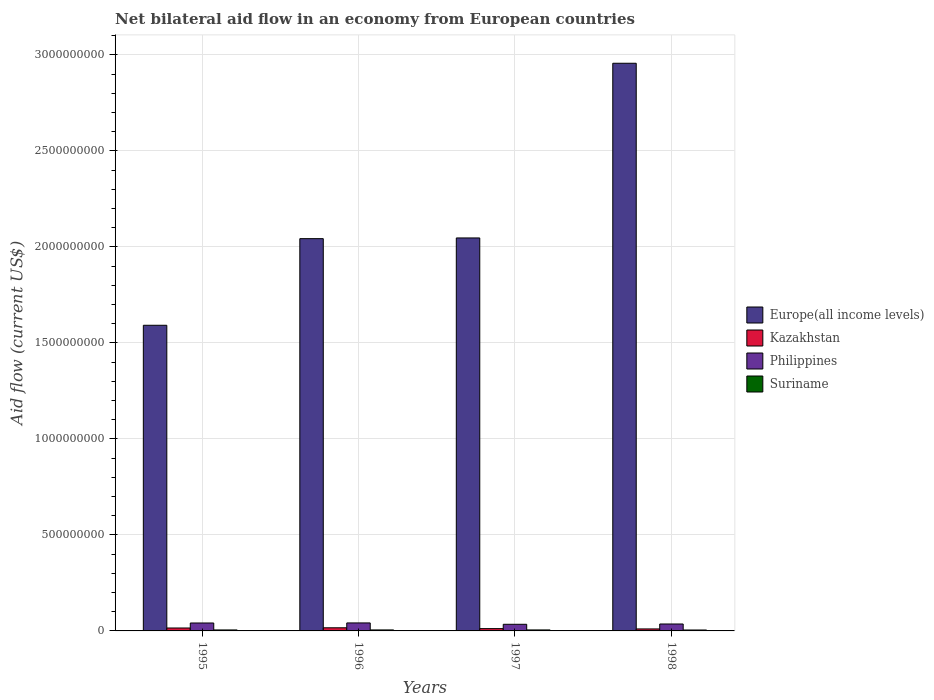How many different coloured bars are there?
Make the answer very short. 4. How many groups of bars are there?
Make the answer very short. 4. Are the number of bars on each tick of the X-axis equal?
Offer a very short reply. Yes. How many bars are there on the 2nd tick from the left?
Your answer should be compact. 4. How many bars are there on the 4th tick from the right?
Give a very brief answer. 4. In how many cases, is the number of bars for a given year not equal to the number of legend labels?
Make the answer very short. 0. What is the net bilateral aid flow in Kazakhstan in 1996?
Your answer should be very brief. 1.63e+07. Across all years, what is the maximum net bilateral aid flow in Philippines?
Give a very brief answer. 4.17e+07. Across all years, what is the minimum net bilateral aid flow in Europe(all income levels)?
Offer a very short reply. 1.59e+09. In which year was the net bilateral aid flow in Kazakhstan minimum?
Ensure brevity in your answer.  1998. What is the total net bilateral aid flow in Suriname in the graph?
Offer a very short reply. 2.02e+07. What is the difference between the net bilateral aid flow in Kazakhstan in 1996 and that in 1998?
Provide a short and direct response. 5.98e+06. What is the difference between the net bilateral aid flow in Europe(all income levels) in 1998 and the net bilateral aid flow in Kazakhstan in 1995?
Give a very brief answer. 2.94e+09. What is the average net bilateral aid flow in Suriname per year?
Make the answer very short. 5.06e+06. In the year 1996, what is the difference between the net bilateral aid flow in Philippines and net bilateral aid flow in Europe(all income levels)?
Offer a very short reply. -2.00e+09. What is the ratio of the net bilateral aid flow in Europe(all income levels) in 1995 to that in 1996?
Offer a very short reply. 0.78. Is the net bilateral aid flow in Suriname in 1995 less than that in 1997?
Offer a very short reply. Yes. What is the difference between the highest and the second highest net bilateral aid flow in Kazakhstan?
Keep it short and to the point. 1.10e+06. What is the difference between the highest and the lowest net bilateral aid flow in Europe(all income levels)?
Offer a very short reply. 1.36e+09. Is it the case that in every year, the sum of the net bilateral aid flow in Kazakhstan and net bilateral aid flow in Suriname is greater than the sum of net bilateral aid flow in Philippines and net bilateral aid flow in Europe(all income levels)?
Give a very brief answer. No. What does the 2nd bar from the left in 1996 represents?
Your answer should be very brief. Kazakhstan. What does the 4th bar from the right in 1996 represents?
Give a very brief answer. Europe(all income levels). Is it the case that in every year, the sum of the net bilateral aid flow in Kazakhstan and net bilateral aid flow in Europe(all income levels) is greater than the net bilateral aid flow in Suriname?
Give a very brief answer. Yes. How many bars are there?
Give a very brief answer. 16. Are all the bars in the graph horizontal?
Ensure brevity in your answer.  No. How many years are there in the graph?
Offer a terse response. 4. Does the graph contain grids?
Keep it short and to the point. Yes. How many legend labels are there?
Provide a short and direct response. 4. How are the legend labels stacked?
Offer a terse response. Vertical. What is the title of the graph?
Give a very brief answer. Net bilateral aid flow in an economy from European countries. Does "Oman" appear as one of the legend labels in the graph?
Keep it short and to the point. No. What is the label or title of the Y-axis?
Offer a terse response. Aid flow (current US$). What is the Aid flow (current US$) of Europe(all income levels) in 1995?
Keep it short and to the point. 1.59e+09. What is the Aid flow (current US$) of Kazakhstan in 1995?
Keep it short and to the point. 1.52e+07. What is the Aid flow (current US$) in Philippines in 1995?
Give a very brief answer. 4.13e+07. What is the Aid flow (current US$) of Suriname in 1995?
Provide a succinct answer. 5.12e+06. What is the Aid flow (current US$) in Europe(all income levels) in 1996?
Your answer should be very brief. 2.04e+09. What is the Aid flow (current US$) of Kazakhstan in 1996?
Your response must be concise. 1.63e+07. What is the Aid flow (current US$) in Philippines in 1996?
Provide a short and direct response. 4.17e+07. What is the Aid flow (current US$) of Suriname in 1996?
Offer a terse response. 5.17e+06. What is the Aid flow (current US$) in Europe(all income levels) in 1997?
Offer a very short reply. 2.05e+09. What is the Aid flow (current US$) of Kazakhstan in 1997?
Give a very brief answer. 1.20e+07. What is the Aid flow (current US$) of Philippines in 1997?
Offer a very short reply. 3.45e+07. What is the Aid flow (current US$) in Suriname in 1997?
Offer a terse response. 5.15e+06. What is the Aid flow (current US$) in Europe(all income levels) in 1998?
Make the answer very short. 2.96e+09. What is the Aid flow (current US$) in Kazakhstan in 1998?
Provide a succinct answer. 1.04e+07. What is the Aid flow (current US$) in Philippines in 1998?
Give a very brief answer. 3.61e+07. What is the Aid flow (current US$) of Suriname in 1998?
Provide a succinct answer. 4.81e+06. Across all years, what is the maximum Aid flow (current US$) of Europe(all income levels)?
Make the answer very short. 2.96e+09. Across all years, what is the maximum Aid flow (current US$) in Kazakhstan?
Offer a terse response. 1.63e+07. Across all years, what is the maximum Aid flow (current US$) in Philippines?
Offer a very short reply. 4.17e+07. Across all years, what is the maximum Aid flow (current US$) in Suriname?
Your response must be concise. 5.17e+06. Across all years, what is the minimum Aid flow (current US$) of Europe(all income levels)?
Give a very brief answer. 1.59e+09. Across all years, what is the minimum Aid flow (current US$) in Kazakhstan?
Keep it short and to the point. 1.04e+07. Across all years, what is the minimum Aid flow (current US$) in Philippines?
Give a very brief answer. 3.45e+07. Across all years, what is the minimum Aid flow (current US$) of Suriname?
Your response must be concise. 4.81e+06. What is the total Aid flow (current US$) of Europe(all income levels) in the graph?
Ensure brevity in your answer.  8.64e+09. What is the total Aid flow (current US$) of Kazakhstan in the graph?
Give a very brief answer. 5.39e+07. What is the total Aid flow (current US$) of Philippines in the graph?
Provide a short and direct response. 1.54e+08. What is the total Aid flow (current US$) in Suriname in the graph?
Offer a terse response. 2.02e+07. What is the difference between the Aid flow (current US$) in Europe(all income levels) in 1995 and that in 1996?
Keep it short and to the point. -4.51e+08. What is the difference between the Aid flow (current US$) in Kazakhstan in 1995 and that in 1996?
Keep it short and to the point. -1.10e+06. What is the difference between the Aid flow (current US$) of Europe(all income levels) in 1995 and that in 1997?
Ensure brevity in your answer.  -4.55e+08. What is the difference between the Aid flow (current US$) of Kazakhstan in 1995 and that in 1997?
Your answer should be very brief. 3.25e+06. What is the difference between the Aid flow (current US$) in Philippines in 1995 and that in 1997?
Make the answer very short. 6.81e+06. What is the difference between the Aid flow (current US$) of Suriname in 1995 and that in 1997?
Provide a succinct answer. -3.00e+04. What is the difference between the Aid flow (current US$) in Europe(all income levels) in 1995 and that in 1998?
Your response must be concise. -1.36e+09. What is the difference between the Aid flow (current US$) in Kazakhstan in 1995 and that in 1998?
Provide a succinct answer. 4.88e+06. What is the difference between the Aid flow (current US$) of Philippines in 1995 and that in 1998?
Offer a terse response. 5.23e+06. What is the difference between the Aid flow (current US$) of Europe(all income levels) in 1996 and that in 1997?
Provide a short and direct response. -3.69e+06. What is the difference between the Aid flow (current US$) in Kazakhstan in 1996 and that in 1997?
Provide a succinct answer. 4.35e+06. What is the difference between the Aid flow (current US$) in Philippines in 1996 and that in 1997?
Offer a terse response. 7.15e+06. What is the difference between the Aid flow (current US$) of Europe(all income levels) in 1996 and that in 1998?
Make the answer very short. -9.14e+08. What is the difference between the Aid flow (current US$) of Kazakhstan in 1996 and that in 1998?
Your answer should be very brief. 5.98e+06. What is the difference between the Aid flow (current US$) in Philippines in 1996 and that in 1998?
Offer a very short reply. 5.57e+06. What is the difference between the Aid flow (current US$) in Suriname in 1996 and that in 1998?
Provide a short and direct response. 3.60e+05. What is the difference between the Aid flow (current US$) of Europe(all income levels) in 1997 and that in 1998?
Provide a short and direct response. -9.10e+08. What is the difference between the Aid flow (current US$) of Kazakhstan in 1997 and that in 1998?
Give a very brief answer. 1.63e+06. What is the difference between the Aid flow (current US$) of Philippines in 1997 and that in 1998?
Give a very brief answer. -1.58e+06. What is the difference between the Aid flow (current US$) of Europe(all income levels) in 1995 and the Aid flow (current US$) of Kazakhstan in 1996?
Ensure brevity in your answer.  1.58e+09. What is the difference between the Aid flow (current US$) in Europe(all income levels) in 1995 and the Aid flow (current US$) in Philippines in 1996?
Provide a short and direct response. 1.55e+09. What is the difference between the Aid flow (current US$) in Europe(all income levels) in 1995 and the Aid flow (current US$) in Suriname in 1996?
Keep it short and to the point. 1.59e+09. What is the difference between the Aid flow (current US$) in Kazakhstan in 1995 and the Aid flow (current US$) in Philippines in 1996?
Your answer should be very brief. -2.64e+07. What is the difference between the Aid flow (current US$) of Kazakhstan in 1995 and the Aid flow (current US$) of Suriname in 1996?
Your answer should be compact. 1.01e+07. What is the difference between the Aid flow (current US$) of Philippines in 1995 and the Aid flow (current US$) of Suriname in 1996?
Offer a very short reply. 3.62e+07. What is the difference between the Aid flow (current US$) in Europe(all income levels) in 1995 and the Aid flow (current US$) in Kazakhstan in 1997?
Offer a very short reply. 1.58e+09. What is the difference between the Aid flow (current US$) of Europe(all income levels) in 1995 and the Aid flow (current US$) of Philippines in 1997?
Offer a terse response. 1.56e+09. What is the difference between the Aid flow (current US$) in Europe(all income levels) in 1995 and the Aid flow (current US$) in Suriname in 1997?
Provide a short and direct response. 1.59e+09. What is the difference between the Aid flow (current US$) of Kazakhstan in 1995 and the Aid flow (current US$) of Philippines in 1997?
Your answer should be very brief. -1.93e+07. What is the difference between the Aid flow (current US$) in Kazakhstan in 1995 and the Aid flow (current US$) in Suriname in 1997?
Offer a terse response. 1.01e+07. What is the difference between the Aid flow (current US$) of Philippines in 1995 and the Aid flow (current US$) of Suriname in 1997?
Your answer should be very brief. 3.62e+07. What is the difference between the Aid flow (current US$) in Europe(all income levels) in 1995 and the Aid flow (current US$) in Kazakhstan in 1998?
Make the answer very short. 1.58e+09. What is the difference between the Aid flow (current US$) in Europe(all income levels) in 1995 and the Aid flow (current US$) in Philippines in 1998?
Give a very brief answer. 1.56e+09. What is the difference between the Aid flow (current US$) of Europe(all income levels) in 1995 and the Aid flow (current US$) of Suriname in 1998?
Ensure brevity in your answer.  1.59e+09. What is the difference between the Aid flow (current US$) in Kazakhstan in 1995 and the Aid flow (current US$) in Philippines in 1998?
Provide a short and direct response. -2.08e+07. What is the difference between the Aid flow (current US$) in Kazakhstan in 1995 and the Aid flow (current US$) in Suriname in 1998?
Ensure brevity in your answer.  1.04e+07. What is the difference between the Aid flow (current US$) in Philippines in 1995 and the Aid flow (current US$) in Suriname in 1998?
Offer a very short reply. 3.65e+07. What is the difference between the Aid flow (current US$) in Europe(all income levels) in 1996 and the Aid flow (current US$) in Kazakhstan in 1997?
Ensure brevity in your answer.  2.03e+09. What is the difference between the Aid flow (current US$) of Europe(all income levels) in 1996 and the Aid flow (current US$) of Philippines in 1997?
Your answer should be compact. 2.01e+09. What is the difference between the Aid flow (current US$) in Europe(all income levels) in 1996 and the Aid flow (current US$) in Suriname in 1997?
Your response must be concise. 2.04e+09. What is the difference between the Aid flow (current US$) of Kazakhstan in 1996 and the Aid flow (current US$) of Philippines in 1997?
Your answer should be compact. -1.82e+07. What is the difference between the Aid flow (current US$) of Kazakhstan in 1996 and the Aid flow (current US$) of Suriname in 1997?
Offer a terse response. 1.12e+07. What is the difference between the Aid flow (current US$) in Philippines in 1996 and the Aid flow (current US$) in Suriname in 1997?
Your response must be concise. 3.65e+07. What is the difference between the Aid flow (current US$) in Europe(all income levels) in 1996 and the Aid flow (current US$) in Kazakhstan in 1998?
Your response must be concise. 2.03e+09. What is the difference between the Aid flow (current US$) in Europe(all income levels) in 1996 and the Aid flow (current US$) in Philippines in 1998?
Your answer should be very brief. 2.01e+09. What is the difference between the Aid flow (current US$) in Europe(all income levels) in 1996 and the Aid flow (current US$) in Suriname in 1998?
Provide a short and direct response. 2.04e+09. What is the difference between the Aid flow (current US$) in Kazakhstan in 1996 and the Aid flow (current US$) in Philippines in 1998?
Provide a short and direct response. -1.98e+07. What is the difference between the Aid flow (current US$) in Kazakhstan in 1996 and the Aid flow (current US$) in Suriname in 1998?
Ensure brevity in your answer.  1.15e+07. What is the difference between the Aid flow (current US$) of Philippines in 1996 and the Aid flow (current US$) of Suriname in 1998?
Your answer should be compact. 3.68e+07. What is the difference between the Aid flow (current US$) of Europe(all income levels) in 1997 and the Aid flow (current US$) of Kazakhstan in 1998?
Make the answer very short. 2.04e+09. What is the difference between the Aid flow (current US$) in Europe(all income levels) in 1997 and the Aid flow (current US$) in Philippines in 1998?
Make the answer very short. 2.01e+09. What is the difference between the Aid flow (current US$) of Europe(all income levels) in 1997 and the Aid flow (current US$) of Suriname in 1998?
Keep it short and to the point. 2.04e+09. What is the difference between the Aid flow (current US$) of Kazakhstan in 1997 and the Aid flow (current US$) of Philippines in 1998?
Ensure brevity in your answer.  -2.41e+07. What is the difference between the Aid flow (current US$) in Kazakhstan in 1997 and the Aid flow (current US$) in Suriname in 1998?
Your response must be concise. 7.18e+06. What is the difference between the Aid flow (current US$) of Philippines in 1997 and the Aid flow (current US$) of Suriname in 1998?
Keep it short and to the point. 2.97e+07. What is the average Aid flow (current US$) in Europe(all income levels) per year?
Your answer should be compact. 2.16e+09. What is the average Aid flow (current US$) of Kazakhstan per year?
Make the answer very short. 1.35e+07. What is the average Aid flow (current US$) in Philippines per year?
Your answer should be compact. 3.84e+07. What is the average Aid flow (current US$) of Suriname per year?
Your answer should be compact. 5.06e+06. In the year 1995, what is the difference between the Aid flow (current US$) of Europe(all income levels) and Aid flow (current US$) of Kazakhstan?
Offer a terse response. 1.58e+09. In the year 1995, what is the difference between the Aid flow (current US$) in Europe(all income levels) and Aid flow (current US$) in Philippines?
Make the answer very short. 1.55e+09. In the year 1995, what is the difference between the Aid flow (current US$) of Europe(all income levels) and Aid flow (current US$) of Suriname?
Ensure brevity in your answer.  1.59e+09. In the year 1995, what is the difference between the Aid flow (current US$) in Kazakhstan and Aid flow (current US$) in Philippines?
Your response must be concise. -2.61e+07. In the year 1995, what is the difference between the Aid flow (current US$) in Kazakhstan and Aid flow (current US$) in Suriname?
Your response must be concise. 1.01e+07. In the year 1995, what is the difference between the Aid flow (current US$) in Philippines and Aid flow (current US$) in Suriname?
Offer a terse response. 3.62e+07. In the year 1996, what is the difference between the Aid flow (current US$) of Europe(all income levels) and Aid flow (current US$) of Kazakhstan?
Your response must be concise. 2.03e+09. In the year 1996, what is the difference between the Aid flow (current US$) in Europe(all income levels) and Aid flow (current US$) in Philippines?
Your answer should be compact. 2.00e+09. In the year 1996, what is the difference between the Aid flow (current US$) in Europe(all income levels) and Aid flow (current US$) in Suriname?
Provide a short and direct response. 2.04e+09. In the year 1996, what is the difference between the Aid flow (current US$) of Kazakhstan and Aid flow (current US$) of Philippines?
Your answer should be very brief. -2.53e+07. In the year 1996, what is the difference between the Aid flow (current US$) in Kazakhstan and Aid flow (current US$) in Suriname?
Offer a terse response. 1.12e+07. In the year 1996, what is the difference between the Aid flow (current US$) of Philippines and Aid flow (current US$) of Suriname?
Your answer should be compact. 3.65e+07. In the year 1997, what is the difference between the Aid flow (current US$) in Europe(all income levels) and Aid flow (current US$) in Kazakhstan?
Make the answer very short. 2.04e+09. In the year 1997, what is the difference between the Aid flow (current US$) in Europe(all income levels) and Aid flow (current US$) in Philippines?
Give a very brief answer. 2.01e+09. In the year 1997, what is the difference between the Aid flow (current US$) in Europe(all income levels) and Aid flow (current US$) in Suriname?
Your answer should be compact. 2.04e+09. In the year 1997, what is the difference between the Aid flow (current US$) in Kazakhstan and Aid flow (current US$) in Philippines?
Your response must be concise. -2.25e+07. In the year 1997, what is the difference between the Aid flow (current US$) of Kazakhstan and Aid flow (current US$) of Suriname?
Give a very brief answer. 6.84e+06. In the year 1997, what is the difference between the Aid flow (current US$) in Philippines and Aid flow (current US$) in Suriname?
Your answer should be very brief. 2.94e+07. In the year 1998, what is the difference between the Aid flow (current US$) in Europe(all income levels) and Aid flow (current US$) in Kazakhstan?
Provide a succinct answer. 2.95e+09. In the year 1998, what is the difference between the Aid flow (current US$) in Europe(all income levels) and Aid flow (current US$) in Philippines?
Give a very brief answer. 2.92e+09. In the year 1998, what is the difference between the Aid flow (current US$) of Europe(all income levels) and Aid flow (current US$) of Suriname?
Offer a very short reply. 2.95e+09. In the year 1998, what is the difference between the Aid flow (current US$) of Kazakhstan and Aid flow (current US$) of Philippines?
Offer a very short reply. -2.57e+07. In the year 1998, what is the difference between the Aid flow (current US$) of Kazakhstan and Aid flow (current US$) of Suriname?
Your response must be concise. 5.55e+06. In the year 1998, what is the difference between the Aid flow (current US$) of Philippines and Aid flow (current US$) of Suriname?
Your answer should be compact. 3.13e+07. What is the ratio of the Aid flow (current US$) of Europe(all income levels) in 1995 to that in 1996?
Keep it short and to the point. 0.78. What is the ratio of the Aid flow (current US$) in Kazakhstan in 1995 to that in 1996?
Provide a short and direct response. 0.93. What is the ratio of the Aid flow (current US$) of Suriname in 1995 to that in 1996?
Your answer should be very brief. 0.99. What is the ratio of the Aid flow (current US$) in Kazakhstan in 1995 to that in 1997?
Keep it short and to the point. 1.27. What is the ratio of the Aid flow (current US$) in Philippines in 1995 to that in 1997?
Offer a very short reply. 1.2. What is the ratio of the Aid flow (current US$) of Europe(all income levels) in 1995 to that in 1998?
Ensure brevity in your answer.  0.54. What is the ratio of the Aid flow (current US$) in Kazakhstan in 1995 to that in 1998?
Your answer should be very brief. 1.47. What is the ratio of the Aid flow (current US$) in Philippines in 1995 to that in 1998?
Make the answer very short. 1.14. What is the ratio of the Aid flow (current US$) in Suriname in 1995 to that in 1998?
Your answer should be very brief. 1.06. What is the ratio of the Aid flow (current US$) of Kazakhstan in 1996 to that in 1997?
Offer a very short reply. 1.36. What is the ratio of the Aid flow (current US$) in Philippines in 1996 to that in 1997?
Make the answer very short. 1.21. What is the ratio of the Aid flow (current US$) of Suriname in 1996 to that in 1997?
Ensure brevity in your answer.  1. What is the ratio of the Aid flow (current US$) of Europe(all income levels) in 1996 to that in 1998?
Your answer should be compact. 0.69. What is the ratio of the Aid flow (current US$) in Kazakhstan in 1996 to that in 1998?
Offer a terse response. 1.58. What is the ratio of the Aid flow (current US$) in Philippines in 1996 to that in 1998?
Offer a terse response. 1.15. What is the ratio of the Aid flow (current US$) in Suriname in 1996 to that in 1998?
Keep it short and to the point. 1.07. What is the ratio of the Aid flow (current US$) in Europe(all income levels) in 1997 to that in 1998?
Your answer should be very brief. 0.69. What is the ratio of the Aid flow (current US$) in Kazakhstan in 1997 to that in 1998?
Ensure brevity in your answer.  1.16. What is the ratio of the Aid flow (current US$) of Philippines in 1997 to that in 1998?
Offer a very short reply. 0.96. What is the ratio of the Aid flow (current US$) of Suriname in 1997 to that in 1998?
Provide a succinct answer. 1.07. What is the difference between the highest and the second highest Aid flow (current US$) in Europe(all income levels)?
Your response must be concise. 9.10e+08. What is the difference between the highest and the second highest Aid flow (current US$) in Kazakhstan?
Keep it short and to the point. 1.10e+06. What is the difference between the highest and the second highest Aid flow (current US$) in Philippines?
Your answer should be compact. 3.40e+05. What is the difference between the highest and the second highest Aid flow (current US$) of Suriname?
Ensure brevity in your answer.  2.00e+04. What is the difference between the highest and the lowest Aid flow (current US$) in Europe(all income levels)?
Provide a short and direct response. 1.36e+09. What is the difference between the highest and the lowest Aid flow (current US$) of Kazakhstan?
Provide a succinct answer. 5.98e+06. What is the difference between the highest and the lowest Aid flow (current US$) in Philippines?
Your answer should be compact. 7.15e+06. 